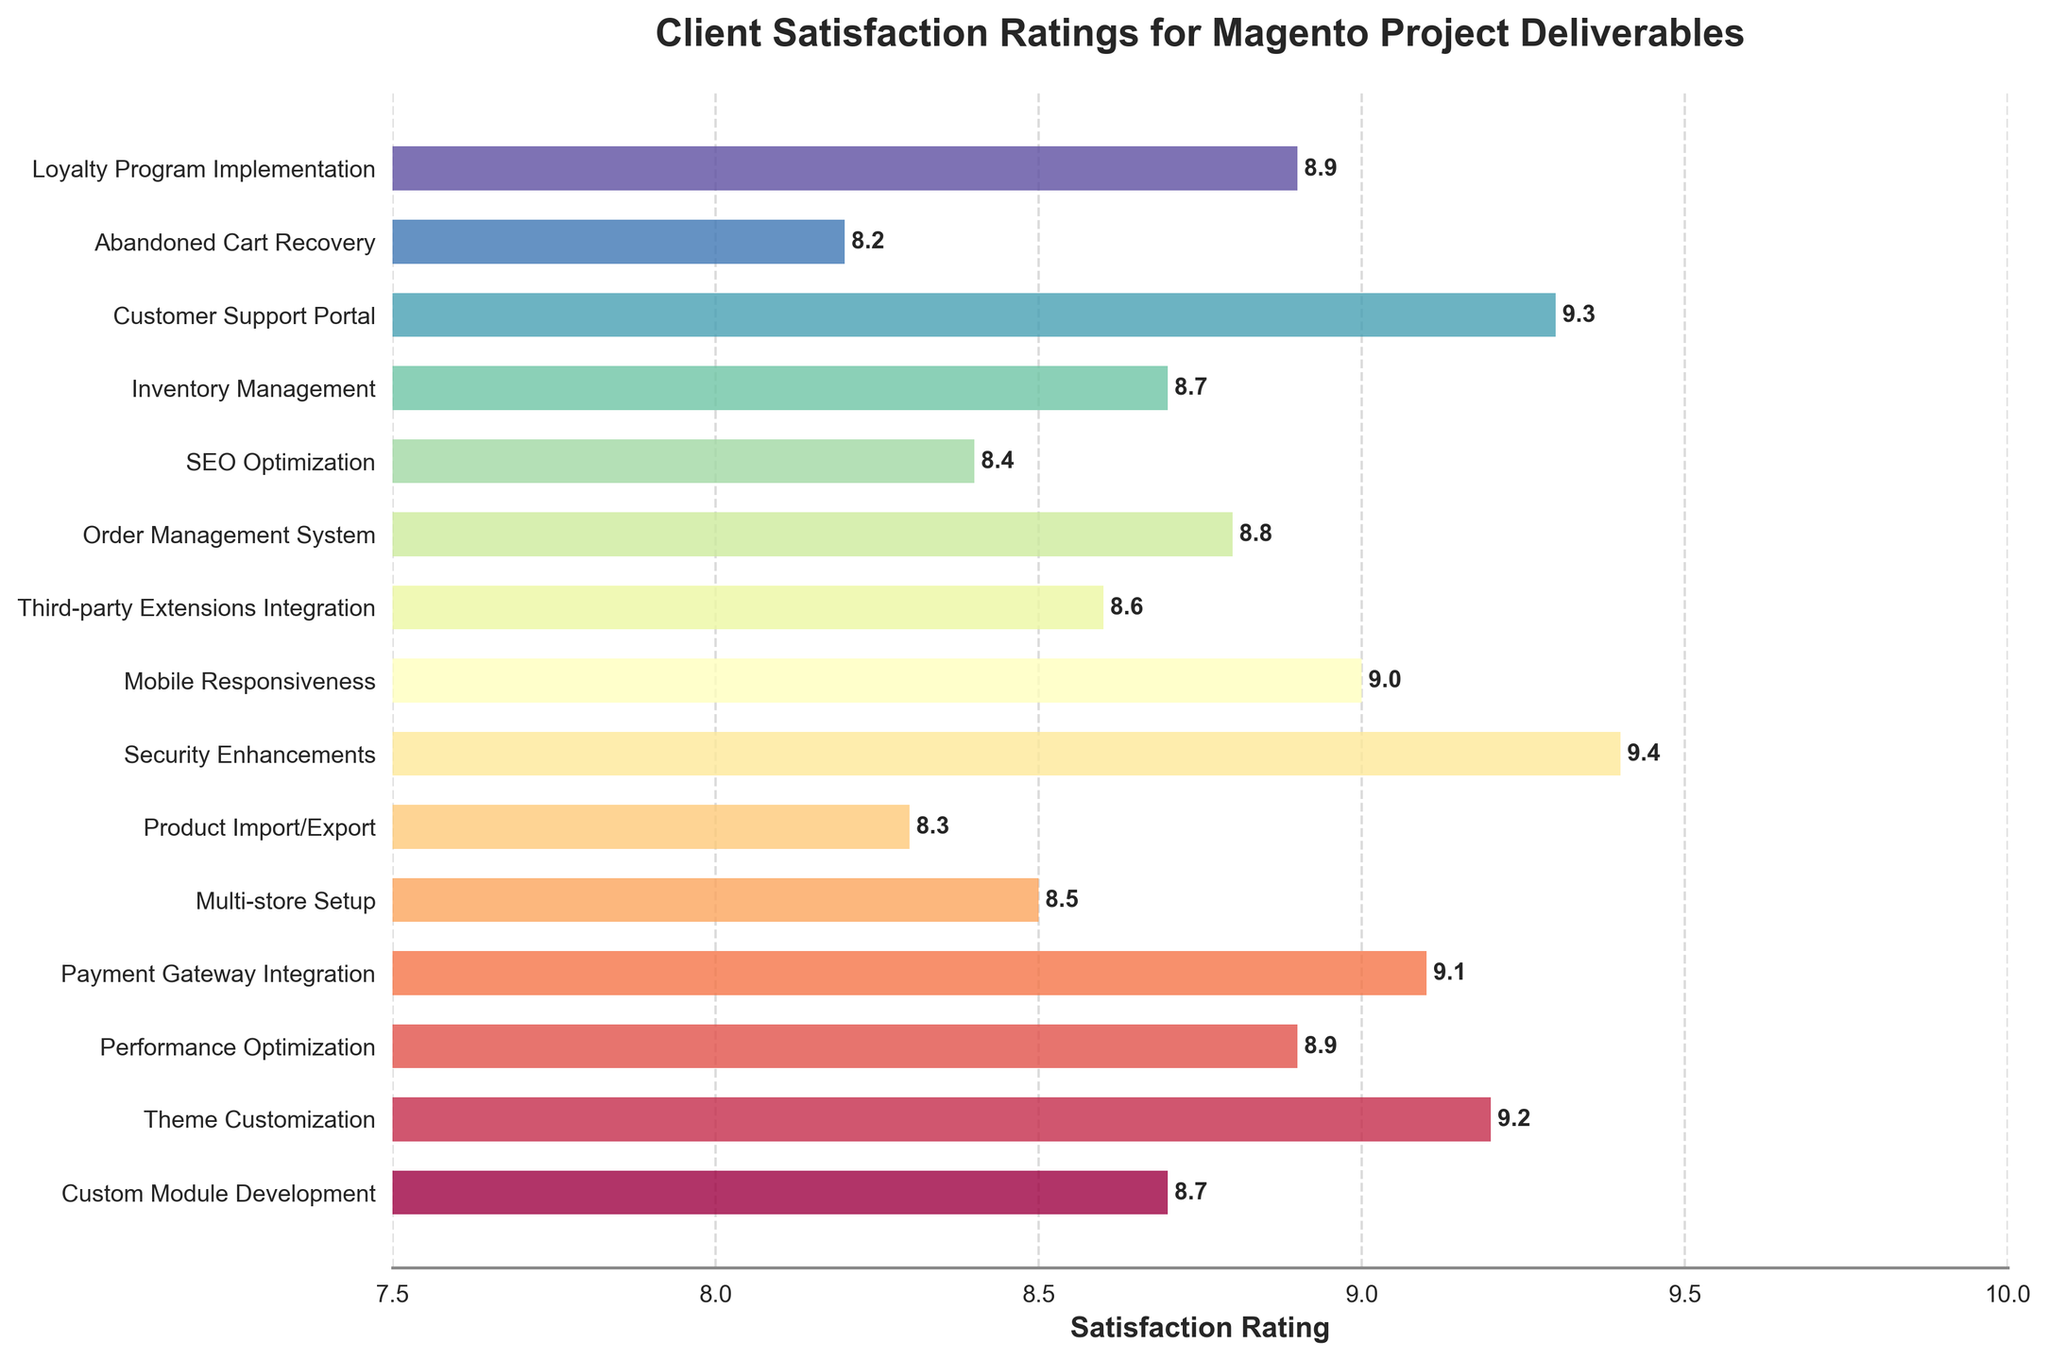What's the average satisfaction rating for all deliverables? First, sum all the satisfaction ratings. The total is 8.7 + 9.2 + 8.9 + 9.1 + 8.5 + 8.3 + 9.4 + 9.0 + 8.6 + 8.8 + 8.4 + 8.7 + 9.3 + 8.2 + 8.9 = 132. The number of deliverables is 15. Dividing the total by the number of deliverables gives the average rating: 132/15 = 8.8
Answer: 8.8 Which deliverable has the highest satisfaction rating and what is it? Look at the bar with the longest length. "Security Enhancements" has the highest satisfaction rating of 9.4
Answer: Security Enhancements, 9.4 How does the satisfaction rating for "Theme Customization" compare to "Abandoned Cart Recovery"? Identify the ratings for both deliverables: "Theme Customization" at 9.2 and "Abandoned Cart Recovery" at 8.2. Comparing them, 9.2 is greater than 8.2
Answer: 9.2 > 8.2 Which deliverable has the lowest satisfaction rating and what is it? Look at the bar with the shortest length. "Abandoned Cart Recovery" has the lowest satisfaction rating of 8.2
Answer: Abandoned Cart Recovery, 8.2 What is the combined satisfaction rating for "Payment Gateway Integration" and "Multi-store Setup"? Sum the satisfaction ratings for both deliverables. "Payment Gateway Integration" is 9.1 and "Multi-store Setup" is 8.5. The combined rating is 9.1 + 8.5 = 17.6
Answer: 17.6 Are the satisfaction ratings for "Inventory Management" and "Custom Module Development" equal? Identify the ratings for both deliverables. "Inventory Management" is 8.7 and "Custom Module Development" is also 8.7. They are equal
Answer: Yes What is the difference between the highest and lowest satisfaction ratings? The highest rating is 9.4 (Security Enhancements) and the lowest rating is 8.2 (Abandoned Cart Recovery). The difference is 9.4 - 8.2 = 1.2
Answer: 1.2 Which three deliverables have the highest satisfaction ratings? The three bars with the longest lengths are "Security Enhancements" (9.4), "Customer Support Portal" (9.3), and "Theme Customization" (9.2)
Answer: Security Enhancements, Customer Support Portal, Theme Customization What is the average satisfaction rating for "Performance Optimization", "Loyalty Program Implementation", and "Order Management System"? Sum the ratings for these deliverables. "Performance Optimization" (8.9), "Loyalty Program Implementation" (8.9), and "Order Management System" (8.8). The total is 8.9 + 8.9 + 8.8 = 26.6. The average rating is 26.6/3 = 8.87
Answer: 8.87 What is the satisfaction rating for "SEO Optimization" and how does it compare to the deliverable with the median rating? Identify "SEO Optimization" rating (8.4). The median rating is found by sorting all 15 ratings and identifying the middle one, which is "Mobile Responsiveness" (9.0). Comparing them, 8.4 is less than 9.0
Answer: 8.4 < 9.0 